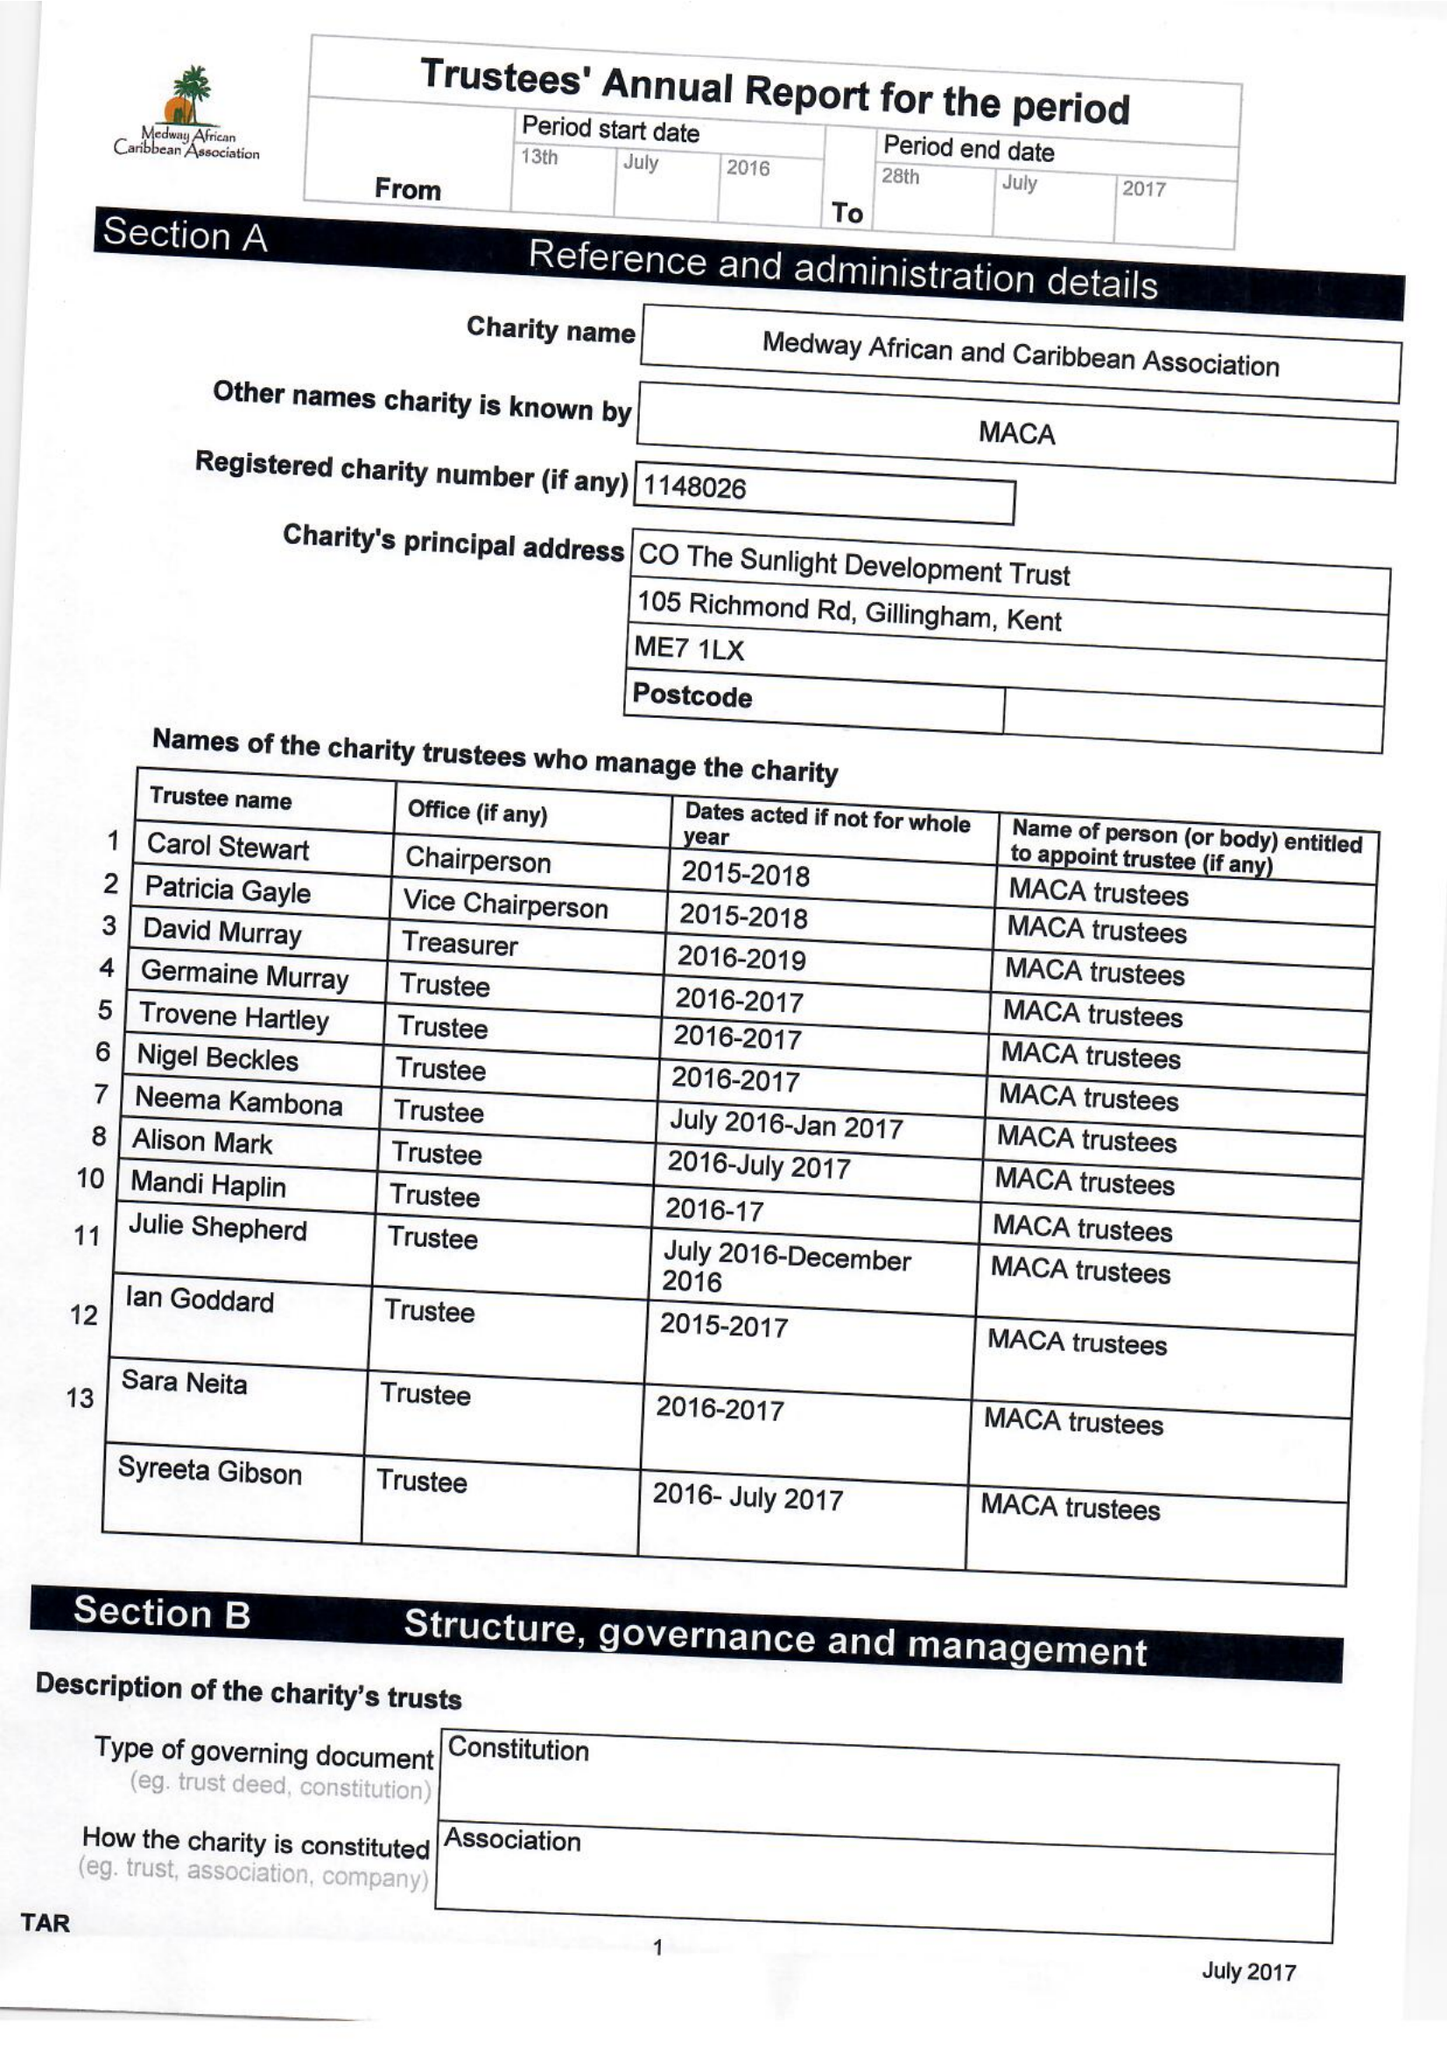What is the value for the income_annually_in_british_pounds?
Answer the question using a single word or phrase. 37740.46 